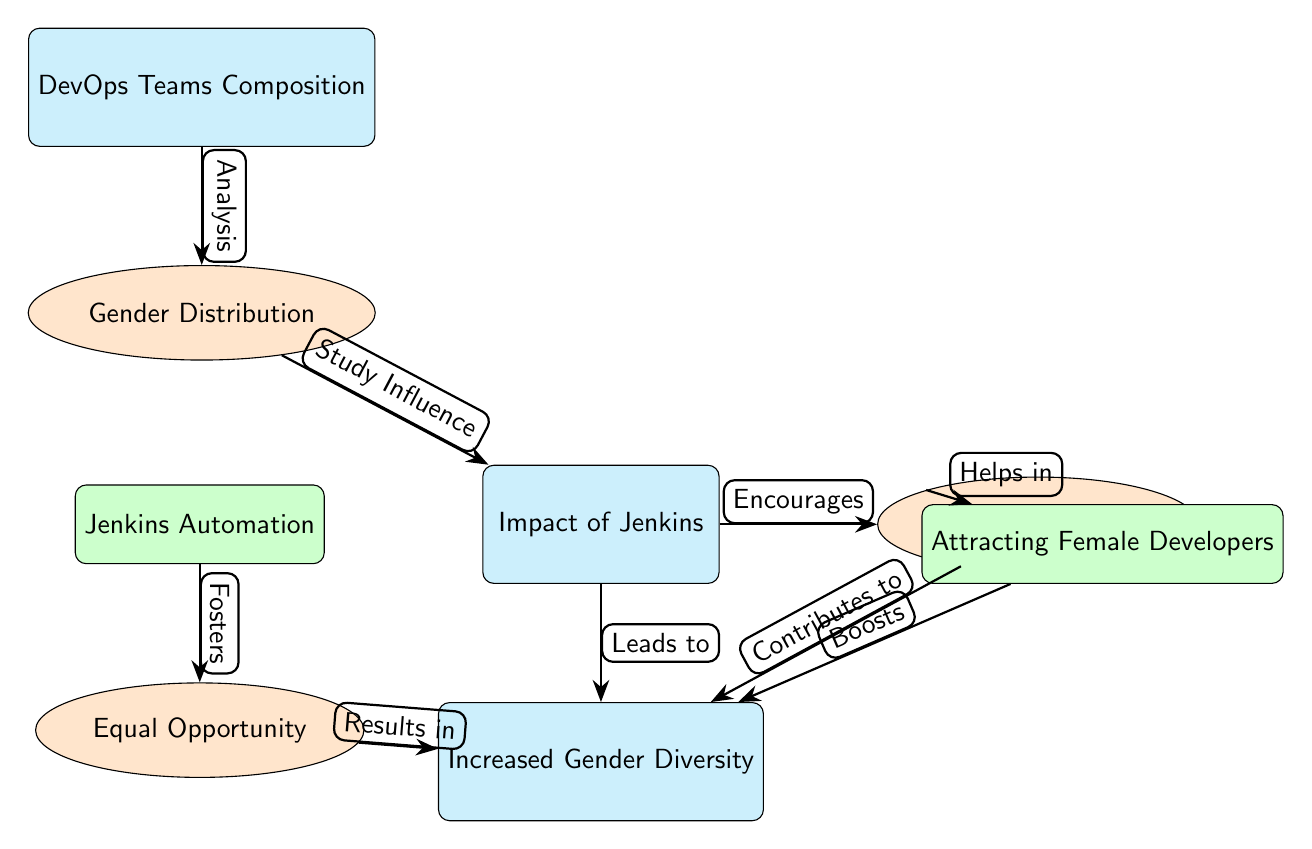What is the main theme of the diagram? The diagram presents the theme of gender distribution within DevOps teams and how Jenkins implementation influences this diversity. The primary focus is on understanding the interconnections between various elements, particularly how Jenkins impacts gender diversity in the workforce.
Answer: Gender Distribution in DevOps Teams How many main nodes are in the diagram? The diagram contains four main nodes, which are highlighted in cyan. They are: "DevOps Teams Composition," "Impact of Jenkins," "Increased Gender Diversity," and "Jenkins Automation."
Answer: Four What node is directly influenced by "Skill Development"? The node that is directly influenced by "Skill Development" is "Increased Gender Diversity." This connection suggests that skill development contributes to enhancing gender diversity in DevOps teams.
Answer: Increased Gender Diversity What does "Jenkins Automation" foster? "Jenkins Automation" fosters "Equal Opportunity." This relationship indicates that the automation provided by Jenkins plays a role in creating equal opportunities within the team context.
Answer: Equal Opportunity Which node contributes to "Increased Gender Diversity"? The node that contributes to "Increased Gender Diversity" is "Skill Development." The diagram indicates that skill development is a factor that leads to greater gender diversity in DevOps teams.
Answer: Skill Development How does "Jenkins Implementation" relate to "Study Influence"? "Jenkins Implementation" is connected to "Study Influence" through the node "Gender Distribution," indicating that the implementation of Jenkins has a studied effect on the distribution of gender in DevOps teams.
Answer: Study Influence What is the relationship between "Skill Development" and "Attracting Female Developers"? "Skill Development" helps in "Attracting Female Developers." This relationship shows that improving skills within the team environment can have a positive effect on drawing more female talent into these roles.
Answer: Helps in How does "Equal Opportunity" impact "Increased Gender Diversity"? "Equal Opportunity" results in "Increased Gender Diversity." The arrow indicates that fostering equal opportunity within the team plays a crucial role in enhancing gender diversity.
Answer: Results in What is a consequence of "Attracting Female Developers"? A consequence of "Attracting Female Developers" is that it boosts "Increased Gender Diversity." This suggests that attracting more female developers directly correlates with an increase in overall gender diversity.
Answer: Boosts 